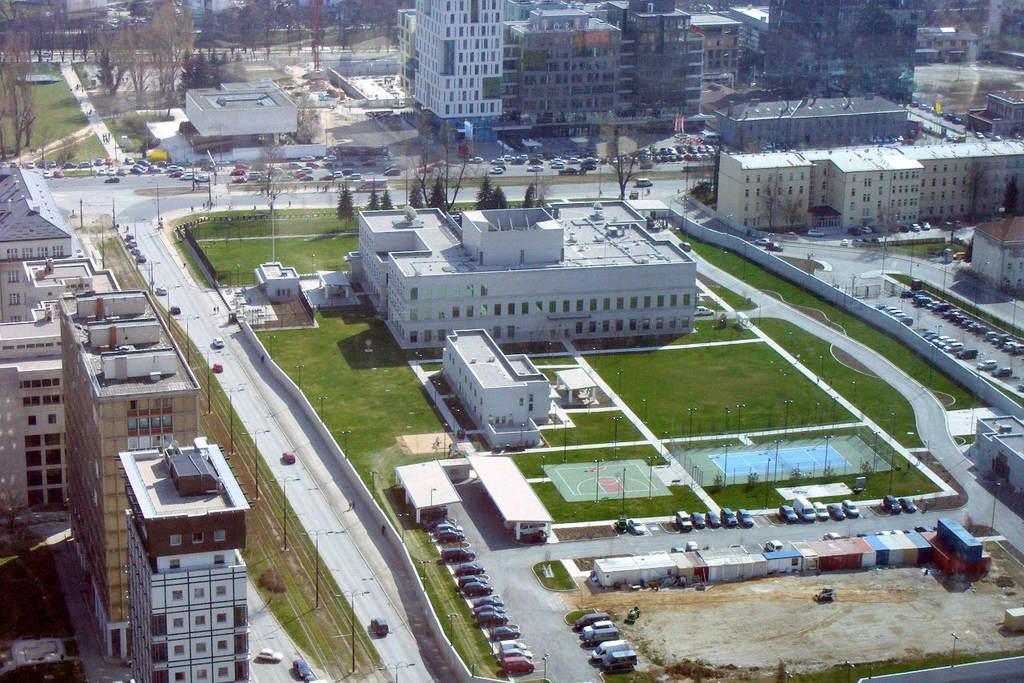Please provide a concise description of this image. In this image I can see the vehicles on the road. In the background, I can see the buildings and the trees. 